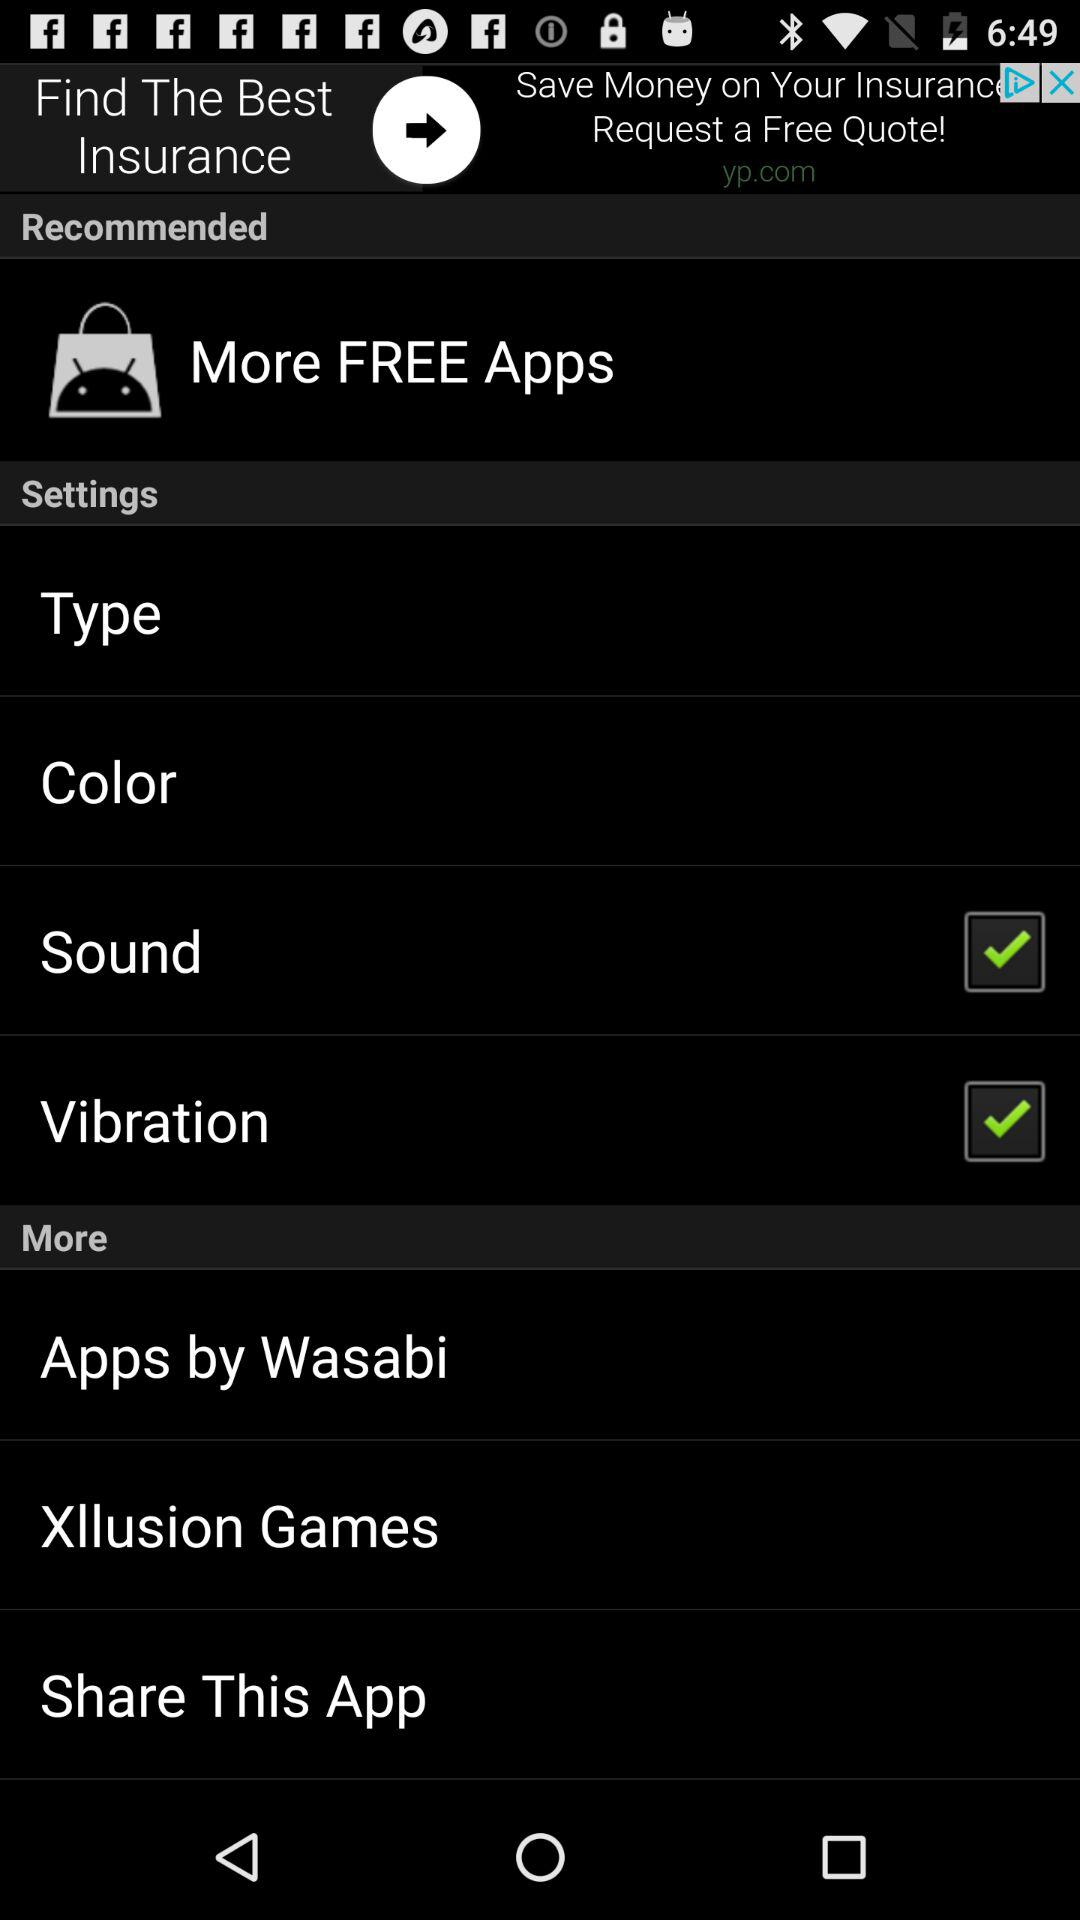What is the status of "Sound"? The status is "on". 